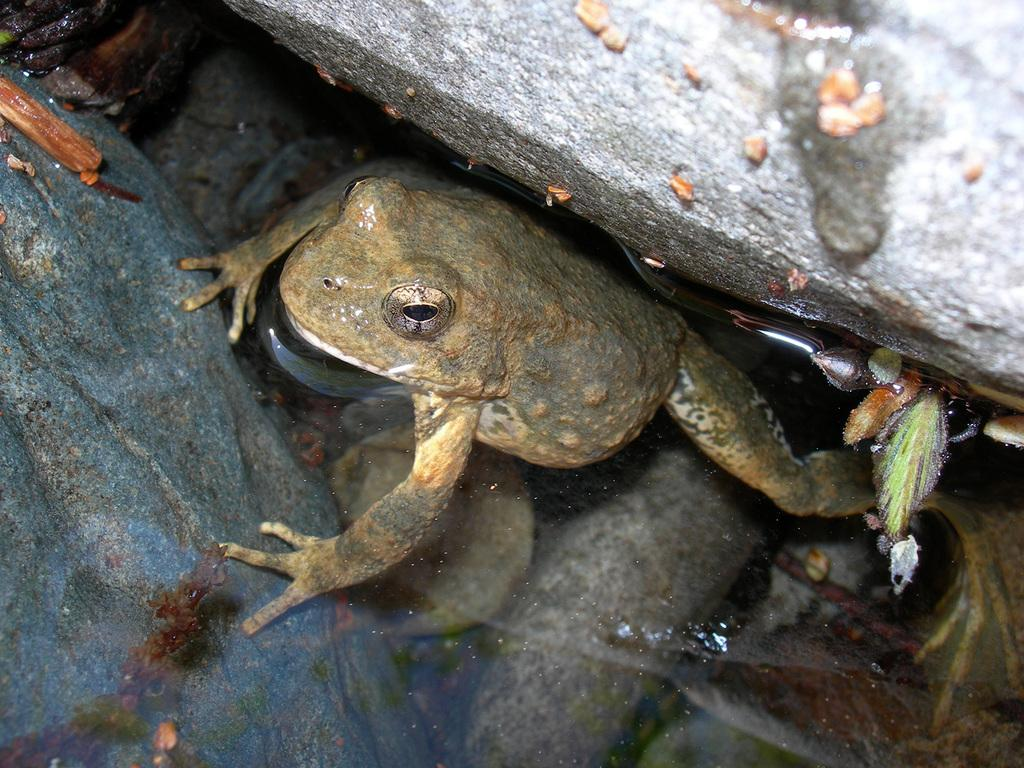What animal can be seen in the water in the image? There is a frog in the water in the image. What is located at the top of the image? There is a rock at the top of the image. Where is the other rock in the image? There is a rock on the left side of the image. What type of laborer is depicted on the canvas in the image? There is no canvas or laborer present in the image. What answer is provided by the frog in the water? The frog in the water does not provide an answer, as it is an animal and not capable of answering questions. 